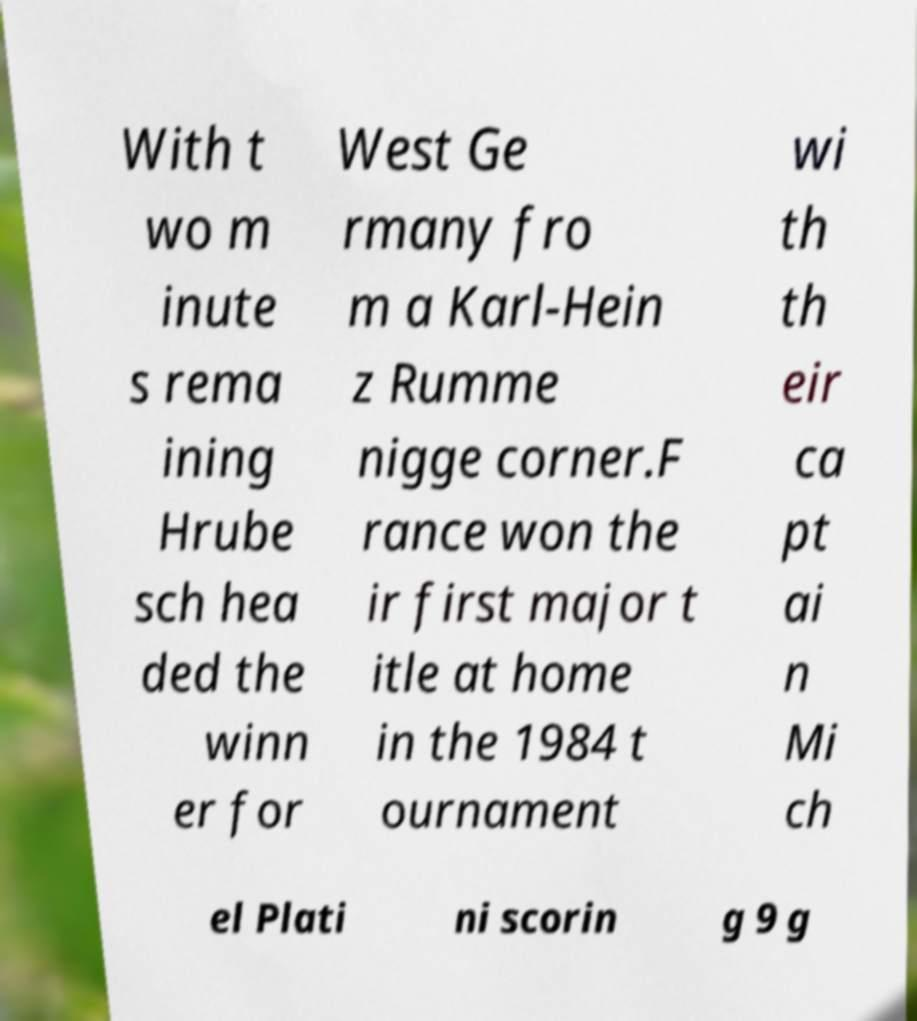What messages or text are displayed in this image? I need them in a readable, typed format. With t wo m inute s rema ining Hrube sch hea ded the winn er for West Ge rmany fro m a Karl-Hein z Rumme nigge corner.F rance won the ir first major t itle at home in the 1984 t ournament wi th th eir ca pt ai n Mi ch el Plati ni scorin g 9 g 